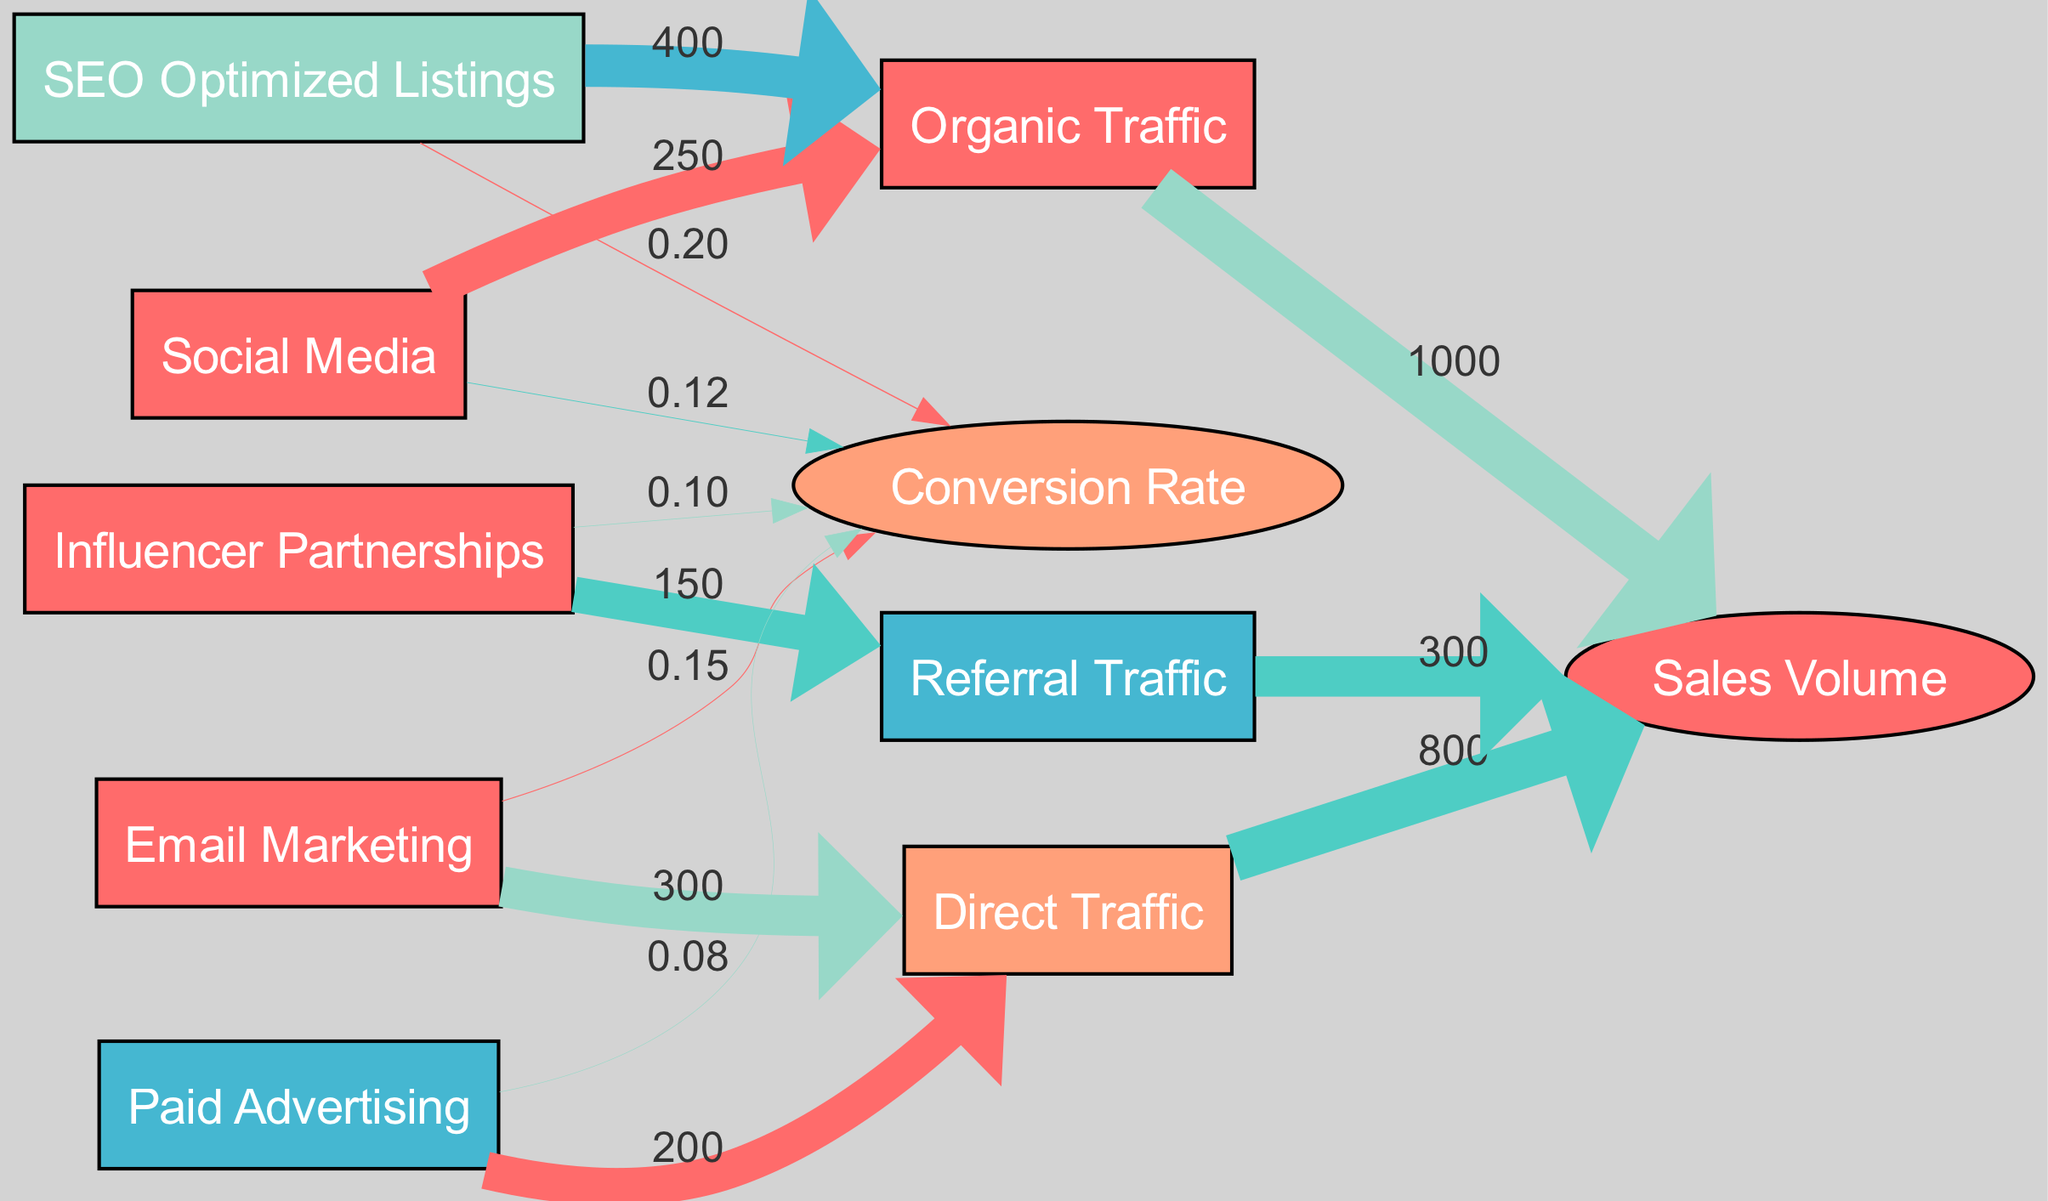What is the total value of traffic generated from Social Media? The diagram shows that Social Media drives 250 traffic to Organic Traffic. This is the only link coming from Social Media.
Answer: 250 What is the conversion rate for SEO Optimized Listings? SEO Optimized Listings has a direct link to Conversion Rate with a value of 0.20 in the diagram. Thus, the conversion rate can be read directly from this link.
Answer: 0.20 How many source nodes are present in the diagram? The diagram depicts five source nodes: Social Media, Email Marketing, Influencer Partnerships, SEO Optimized Listings, and Paid Advertising. We count these nodes to determine the total.
Answer: 5 Which promotional strategy has the highest contribution to Organic Traffic? By comparing the values of the traffic links, SEO Optimized Listings contributes 400, which is higher than the 250 from Social Media. Thus, it has the highest contribution.
Answer: SEO Optimized Listings What is the total sales volume driven by Direct Traffic? The link from Direct Traffic to Sales Volume shows a value of 800. This is a direct reading from the diagram.
Answer: 800 Which promotional strategy has the lowest conversion rate? Comparing conversion rates shows Paid Advertising has the lowest value of 0.08. This is found by looking at the link values for conversion rates.
Answer: Paid Advertising What type of traffic does Influencer Partnerships generate? The diagram indicates that Influencer Partnerships leads to Referral Traffic with a value of 150. This directly tells us what type of traffic is generated.
Answer: Referral Traffic What is the combined traffic value from Email Marketing and Paid Advertising to Direct Traffic? From Email Marketing and Paid Advertising, the values are 300 and 200, respectively. Adding these gives us a total traffic value of 500 leading to Direct Traffic.
Answer: 500 What is the total sales volume from Organic Traffic and Referral Traffic combined? The values are 1000 from Organic Traffic and 300 from Referral Traffic. By summing these, the total sales volume is 1300.
Answer: 1300 